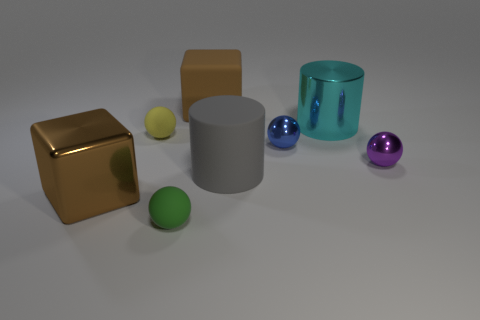Are there any yellow spheres of the same size as the matte cube? no 